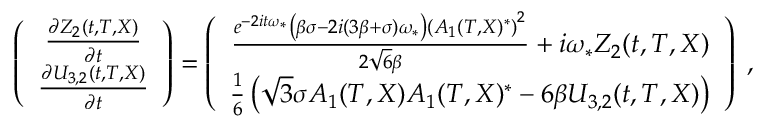Convert formula to latex. <formula><loc_0><loc_0><loc_500><loc_500>\begin{array} { r } { \left ( \begin{array} { c } { \frac { \partial Z _ { 2 } ( t , T , X ) } { \partial t } } \\ { \frac { \partial U _ { 3 , 2 } ( t , T , X ) } { \partial t } } \end{array} \right ) = \left ( \begin{array} { c } { \frac { e ^ { - 2 i t \omega _ { * } } \left ( \beta \sigma - 2 i ( 3 \beta + \sigma ) \omega _ { * } \right ) \left ( A _ { 1 } ( T , X ) ^ { * } \right ) ^ { 2 } } { 2 \sqrt { 6 } \beta } + i \omega _ { * } Z _ { 2 } ( t , T , X ) } \\ { \frac { 1 } { 6 } \left ( \sqrt { 3 } \sigma A _ { 1 } ( T , X ) A _ { 1 } ( T , X ) ^ { * } - 6 \beta U _ { 3 , 2 } ( t , T , X ) \right ) } \end{array} \right ) \, , } \end{array}</formula> 